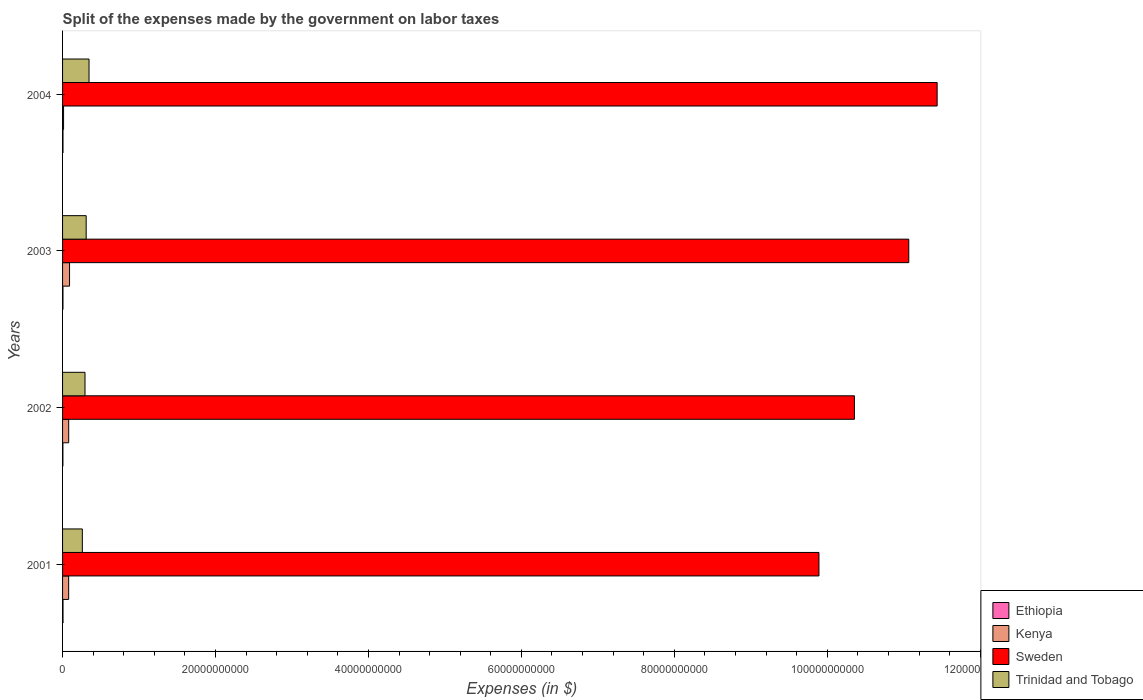How many different coloured bars are there?
Keep it short and to the point. 4. How many groups of bars are there?
Offer a terse response. 4. Are the number of bars on each tick of the Y-axis equal?
Provide a short and direct response. Yes. How many bars are there on the 3rd tick from the top?
Your answer should be compact. 4. How many bars are there on the 1st tick from the bottom?
Provide a short and direct response. 4. What is the label of the 1st group of bars from the top?
Ensure brevity in your answer.  2004. What is the expenses made by the government on labor taxes in Trinidad and Tobago in 2002?
Make the answer very short. 2.93e+09. Across all years, what is the maximum expenses made by the government on labor taxes in Sweden?
Your response must be concise. 1.14e+11. Across all years, what is the minimum expenses made by the government on labor taxes in Trinidad and Tobago?
Ensure brevity in your answer.  2.59e+09. In which year was the expenses made by the government on labor taxes in Trinidad and Tobago minimum?
Give a very brief answer. 2001. What is the total expenses made by the government on labor taxes in Sweden in the graph?
Your answer should be compact. 4.27e+11. What is the difference between the expenses made by the government on labor taxes in Trinidad and Tobago in 2002 and that in 2003?
Your answer should be very brief. -1.53e+08. What is the difference between the expenses made by the government on labor taxes in Ethiopia in 2003 and the expenses made by the government on labor taxes in Sweden in 2002?
Provide a succinct answer. -1.04e+11. What is the average expenses made by the government on labor taxes in Ethiopia per year?
Provide a succinct answer. 5.30e+07. In the year 2003, what is the difference between the expenses made by the government on labor taxes in Sweden and expenses made by the government on labor taxes in Kenya?
Keep it short and to the point. 1.10e+11. What is the ratio of the expenses made by the government on labor taxes in Trinidad and Tobago in 2001 to that in 2003?
Make the answer very short. 0.84. Is the expenses made by the government on labor taxes in Ethiopia in 2003 less than that in 2004?
Your answer should be compact. Yes. What is the difference between the highest and the lowest expenses made by the government on labor taxes in Sweden?
Provide a short and direct response. 1.55e+1. Is it the case that in every year, the sum of the expenses made by the government on labor taxes in Kenya and expenses made by the government on labor taxes in Sweden is greater than the sum of expenses made by the government on labor taxes in Trinidad and Tobago and expenses made by the government on labor taxes in Ethiopia?
Offer a terse response. Yes. What does the 3rd bar from the top in 2002 represents?
Ensure brevity in your answer.  Kenya. What does the 4th bar from the bottom in 2003 represents?
Provide a succinct answer. Trinidad and Tobago. Is it the case that in every year, the sum of the expenses made by the government on labor taxes in Trinidad and Tobago and expenses made by the government on labor taxes in Ethiopia is greater than the expenses made by the government on labor taxes in Sweden?
Provide a short and direct response. No. How many years are there in the graph?
Your answer should be compact. 4. What is the difference between two consecutive major ticks on the X-axis?
Your answer should be compact. 2.00e+1. How many legend labels are there?
Your response must be concise. 4. How are the legend labels stacked?
Your answer should be very brief. Vertical. What is the title of the graph?
Provide a short and direct response. Split of the expenses made by the government on labor taxes. Does "Montenegro" appear as one of the legend labels in the graph?
Make the answer very short. No. What is the label or title of the X-axis?
Make the answer very short. Expenses (in $). What is the Expenses (in $) of Ethiopia in 2001?
Provide a short and direct response. 5.79e+07. What is the Expenses (in $) of Kenya in 2001?
Provide a succinct answer. 7.97e+08. What is the Expenses (in $) of Sweden in 2001?
Keep it short and to the point. 9.89e+1. What is the Expenses (in $) of Trinidad and Tobago in 2001?
Offer a terse response. 2.59e+09. What is the Expenses (in $) of Ethiopia in 2002?
Your answer should be compact. 4.51e+07. What is the Expenses (in $) in Kenya in 2002?
Keep it short and to the point. 8.01e+08. What is the Expenses (in $) in Sweden in 2002?
Provide a short and direct response. 1.04e+11. What is the Expenses (in $) of Trinidad and Tobago in 2002?
Your answer should be very brief. 2.93e+09. What is the Expenses (in $) in Ethiopia in 2003?
Your answer should be compact. 5.20e+07. What is the Expenses (in $) of Kenya in 2003?
Offer a terse response. 9.14e+08. What is the Expenses (in $) of Sweden in 2003?
Keep it short and to the point. 1.11e+11. What is the Expenses (in $) of Trinidad and Tobago in 2003?
Your answer should be very brief. 3.09e+09. What is the Expenses (in $) in Ethiopia in 2004?
Ensure brevity in your answer.  5.71e+07. What is the Expenses (in $) of Kenya in 2004?
Provide a short and direct response. 1.31e+08. What is the Expenses (in $) in Sweden in 2004?
Keep it short and to the point. 1.14e+11. What is the Expenses (in $) in Trinidad and Tobago in 2004?
Your response must be concise. 3.46e+09. Across all years, what is the maximum Expenses (in $) in Ethiopia?
Offer a very short reply. 5.79e+07. Across all years, what is the maximum Expenses (in $) in Kenya?
Your answer should be compact. 9.14e+08. Across all years, what is the maximum Expenses (in $) of Sweden?
Ensure brevity in your answer.  1.14e+11. Across all years, what is the maximum Expenses (in $) of Trinidad and Tobago?
Offer a terse response. 3.46e+09. Across all years, what is the minimum Expenses (in $) of Ethiopia?
Offer a very short reply. 4.51e+07. Across all years, what is the minimum Expenses (in $) in Kenya?
Offer a very short reply. 1.31e+08. Across all years, what is the minimum Expenses (in $) of Sweden?
Ensure brevity in your answer.  9.89e+1. Across all years, what is the minimum Expenses (in $) in Trinidad and Tobago?
Your answer should be compact. 2.59e+09. What is the total Expenses (in $) of Ethiopia in the graph?
Give a very brief answer. 2.12e+08. What is the total Expenses (in $) in Kenya in the graph?
Your response must be concise. 2.64e+09. What is the total Expenses (in $) of Sweden in the graph?
Your answer should be very brief. 4.27e+11. What is the total Expenses (in $) in Trinidad and Tobago in the graph?
Provide a succinct answer. 1.21e+1. What is the difference between the Expenses (in $) of Ethiopia in 2001 and that in 2002?
Keep it short and to the point. 1.28e+07. What is the difference between the Expenses (in $) of Kenya in 2001 and that in 2002?
Keep it short and to the point. -4.44e+06. What is the difference between the Expenses (in $) of Sweden in 2001 and that in 2002?
Make the answer very short. -4.64e+09. What is the difference between the Expenses (in $) of Trinidad and Tobago in 2001 and that in 2002?
Your answer should be very brief. -3.48e+08. What is the difference between the Expenses (in $) in Ethiopia in 2001 and that in 2003?
Provide a succinct answer. 5.90e+06. What is the difference between the Expenses (in $) of Kenya in 2001 and that in 2003?
Offer a terse response. -1.17e+08. What is the difference between the Expenses (in $) of Sweden in 2001 and that in 2003?
Your response must be concise. -1.17e+1. What is the difference between the Expenses (in $) of Trinidad and Tobago in 2001 and that in 2003?
Your answer should be very brief. -5.01e+08. What is the difference between the Expenses (in $) of Kenya in 2001 and that in 2004?
Make the answer very short. 6.66e+08. What is the difference between the Expenses (in $) in Sweden in 2001 and that in 2004?
Provide a short and direct response. -1.55e+1. What is the difference between the Expenses (in $) in Trinidad and Tobago in 2001 and that in 2004?
Offer a terse response. -8.74e+08. What is the difference between the Expenses (in $) of Ethiopia in 2002 and that in 2003?
Provide a short and direct response. -6.90e+06. What is the difference between the Expenses (in $) of Kenya in 2002 and that in 2003?
Make the answer very short. -1.13e+08. What is the difference between the Expenses (in $) of Sweden in 2002 and that in 2003?
Provide a succinct answer. -7.11e+09. What is the difference between the Expenses (in $) of Trinidad and Tobago in 2002 and that in 2003?
Provide a succinct answer. -1.53e+08. What is the difference between the Expenses (in $) of Ethiopia in 2002 and that in 2004?
Your answer should be compact. -1.20e+07. What is the difference between the Expenses (in $) of Kenya in 2002 and that in 2004?
Keep it short and to the point. 6.70e+08. What is the difference between the Expenses (in $) of Sweden in 2002 and that in 2004?
Provide a succinct answer. -1.08e+1. What is the difference between the Expenses (in $) of Trinidad and Tobago in 2002 and that in 2004?
Offer a very short reply. -5.26e+08. What is the difference between the Expenses (in $) in Ethiopia in 2003 and that in 2004?
Give a very brief answer. -5.10e+06. What is the difference between the Expenses (in $) in Kenya in 2003 and that in 2004?
Your answer should be compact. 7.83e+08. What is the difference between the Expenses (in $) in Sweden in 2003 and that in 2004?
Make the answer very short. -3.71e+09. What is the difference between the Expenses (in $) of Trinidad and Tobago in 2003 and that in 2004?
Make the answer very short. -3.72e+08. What is the difference between the Expenses (in $) of Ethiopia in 2001 and the Expenses (in $) of Kenya in 2002?
Give a very brief answer. -7.43e+08. What is the difference between the Expenses (in $) in Ethiopia in 2001 and the Expenses (in $) in Sweden in 2002?
Offer a terse response. -1.03e+11. What is the difference between the Expenses (in $) in Ethiopia in 2001 and the Expenses (in $) in Trinidad and Tobago in 2002?
Offer a terse response. -2.88e+09. What is the difference between the Expenses (in $) in Kenya in 2001 and the Expenses (in $) in Sweden in 2002?
Ensure brevity in your answer.  -1.03e+11. What is the difference between the Expenses (in $) of Kenya in 2001 and the Expenses (in $) of Trinidad and Tobago in 2002?
Provide a short and direct response. -2.14e+09. What is the difference between the Expenses (in $) in Sweden in 2001 and the Expenses (in $) in Trinidad and Tobago in 2002?
Ensure brevity in your answer.  9.60e+1. What is the difference between the Expenses (in $) in Ethiopia in 2001 and the Expenses (in $) in Kenya in 2003?
Offer a terse response. -8.56e+08. What is the difference between the Expenses (in $) in Ethiopia in 2001 and the Expenses (in $) in Sweden in 2003?
Keep it short and to the point. -1.11e+11. What is the difference between the Expenses (in $) in Ethiopia in 2001 and the Expenses (in $) in Trinidad and Tobago in 2003?
Provide a short and direct response. -3.03e+09. What is the difference between the Expenses (in $) of Kenya in 2001 and the Expenses (in $) of Sweden in 2003?
Your answer should be compact. -1.10e+11. What is the difference between the Expenses (in $) in Kenya in 2001 and the Expenses (in $) in Trinidad and Tobago in 2003?
Make the answer very short. -2.29e+09. What is the difference between the Expenses (in $) in Sweden in 2001 and the Expenses (in $) in Trinidad and Tobago in 2003?
Make the answer very short. 9.58e+1. What is the difference between the Expenses (in $) of Ethiopia in 2001 and the Expenses (in $) of Kenya in 2004?
Offer a terse response. -7.31e+07. What is the difference between the Expenses (in $) of Ethiopia in 2001 and the Expenses (in $) of Sweden in 2004?
Make the answer very short. -1.14e+11. What is the difference between the Expenses (in $) in Ethiopia in 2001 and the Expenses (in $) in Trinidad and Tobago in 2004?
Your answer should be compact. -3.40e+09. What is the difference between the Expenses (in $) of Kenya in 2001 and the Expenses (in $) of Sweden in 2004?
Your answer should be very brief. -1.14e+11. What is the difference between the Expenses (in $) in Kenya in 2001 and the Expenses (in $) in Trinidad and Tobago in 2004?
Offer a very short reply. -2.66e+09. What is the difference between the Expenses (in $) in Sweden in 2001 and the Expenses (in $) in Trinidad and Tobago in 2004?
Your answer should be compact. 9.55e+1. What is the difference between the Expenses (in $) in Ethiopia in 2002 and the Expenses (in $) in Kenya in 2003?
Keep it short and to the point. -8.69e+08. What is the difference between the Expenses (in $) of Ethiopia in 2002 and the Expenses (in $) of Sweden in 2003?
Offer a terse response. -1.11e+11. What is the difference between the Expenses (in $) of Ethiopia in 2002 and the Expenses (in $) of Trinidad and Tobago in 2003?
Make the answer very short. -3.04e+09. What is the difference between the Expenses (in $) of Kenya in 2002 and the Expenses (in $) of Sweden in 2003?
Provide a short and direct response. -1.10e+11. What is the difference between the Expenses (in $) in Kenya in 2002 and the Expenses (in $) in Trinidad and Tobago in 2003?
Keep it short and to the point. -2.29e+09. What is the difference between the Expenses (in $) in Sweden in 2002 and the Expenses (in $) in Trinidad and Tobago in 2003?
Your answer should be very brief. 1.00e+11. What is the difference between the Expenses (in $) of Ethiopia in 2002 and the Expenses (in $) of Kenya in 2004?
Give a very brief answer. -8.59e+07. What is the difference between the Expenses (in $) in Ethiopia in 2002 and the Expenses (in $) in Sweden in 2004?
Ensure brevity in your answer.  -1.14e+11. What is the difference between the Expenses (in $) in Ethiopia in 2002 and the Expenses (in $) in Trinidad and Tobago in 2004?
Provide a succinct answer. -3.41e+09. What is the difference between the Expenses (in $) in Kenya in 2002 and the Expenses (in $) in Sweden in 2004?
Offer a very short reply. -1.14e+11. What is the difference between the Expenses (in $) in Kenya in 2002 and the Expenses (in $) in Trinidad and Tobago in 2004?
Provide a succinct answer. -2.66e+09. What is the difference between the Expenses (in $) in Sweden in 2002 and the Expenses (in $) in Trinidad and Tobago in 2004?
Offer a terse response. 1.00e+11. What is the difference between the Expenses (in $) in Ethiopia in 2003 and the Expenses (in $) in Kenya in 2004?
Your answer should be compact. -7.90e+07. What is the difference between the Expenses (in $) of Ethiopia in 2003 and the Expenses (in $) of Sweden in 2004?
Give a very brief answer. -1.14e+11. What is the difference between the Expenses (in $) in Ethiopia in 2003 and the Expenses (in $) in Trinidad and Tobago in 2004?
Offer a very short reply. -3.41e+09. What is the difference between the Expenses (in $) of Kenya in 2003 and the Expenses (in $) of Sweden in 2004?
Ensure brevity in your answer.  -1.13e+11. What is the difference between the Expenses (in $) in Kenya in 2003 and the Expenses (in $) in Trinidad and Tobago in 2004?
Your answer should be very brief. -2.55e+09. What is the difference between the Expenses (in $) of Sweden in 2003 and the Expenses (in $) of Trinidad and Tobago in 2004?
Make the answer very short. 1.07e+11. What is the average Expenses (in $) in Ethiopia per year?
Provide a short and direct response. 5.30e+07. What is the average Expenses (in $) in Kenya per year?
Provide a succinct answer. 6.61e+08. What is the average Expenses (in $) in Sweden per year?
Offer a terse response. 1.07e+11. What is the average Expenses (in $) of Trinidad and Tobago per year?
Offer a very short reply. 3.02e+09. In the year 2001, what is the difference between the Expenses (in $) in Ethiopia and Expenses (in $) in Kenya?
Your answer should be compact. -7.39e+08. In the year 2001, what is the difference between the Expenses (in $) of Ethiopia and Expenses (in $) of Sweden?
Your response must be concise. -9.89e+1. In the year 2001, what is the difference between the Expenses (in $) in Ethiopia and Expenses (in $) in Trinidad and Tobago?
Offer a terse response. -2.53e+09. In the year 2001, what is the difference between the Expenses (in $) of Kenya and Expenses (in $) of Sweden?
Provide a short and direct response. -9.81e+1. In the year 2001, what is the difference between the Expenses (in $) in Kenya and Expenses (in $) in Trinidad and Tobago?
Provide a short and direct response. -1.79e+09. In the year 2001, what is the difference between the Expenses (in $) in Sweden and Expenses (in $) in Trinidad and Tobago?
Keep it short and to the point. 9.63e+1. In the year 2002, what is the difference between the Expenses (in $) of Ethiopia and Expenses (in $) of Kenya?
Make the answer very short. -7.56e+08. In the year 2002, what is the difference between the Expenses (in $) in Ethiopia and Expenses (in $) in Sweden?
Keep it short and to the point. -1.04e+11. In the year 2002, what is the difference between the Expenses (in $) of Ethiopia and Expenses (in $) of Trinidad and Tobago?
Provide a succinct answer. -2.89e+09. In the year 2002, what is the difference between the Expenses (in $) of Kenya and Expenses (in $) of Sweden?
Provide a short and direct response. -1.03e+11. In the year 2002, what is the difference between the Expenses (in $) in Kenya and Expenses (in $) in Trinidad and Tobago?
Your answer should be compact. -2.13e+09. In the year 2002, what is the difference between the Expenses (in $) in Sweden and Expenses (in $) in Trinidad and Tobago?
Offer a terse response. 1.01e+11. In the year 2003, what is the difference between the Expenses (in $) in Ethiopia and Expenses (in $) in Kenya?
Keep it short and to the point. -8.62e+08. In the year 2003, what is the difference between the Expenses (in $) of Ethiopia and Expenses (in $) of Sweden?
Offer a terse response. -1.11e+11. In the year 2003, what is the difference between the Expenses (in $) of Ethiopia and Expenses (in $) of Trinidad and Tobago?
Keep it short and to the point. -3.04e+09. In the year 2003, what is the difference between the Expenses (in $) of Kenya and Expenses (in $) of Sweden?
Provide a succinct answer. -1.10e+11. In the year 2003, what is the difference between the Expenses (in $) in Kenya and Expenses (in $) in Trinidad and Tobago?
Make the answer very short. -2.17e+09. In the year 2003, what is the difference between the Expenses (in $) in Sweden and Expenses (in $) in Trinidad and Tobago?
Keep it short and to the point. 1.08e+11. In the year 2004, what is the difference between the Expenses (in $) in Ethiopia and Expenses (in $) in Kenya?
Ensure brevity in your answer.  -7.39e+07. In the year 2004, what is the difference between the Expenses (in $) in Ethiopia and Expenses (in $) in Sweden?
Make the answer very short. -1.14e+11. In the year 2004, what is the difference between the Expenses (in $) in Ethiopia and Expenses (in $) in Trinidad and Tobago?
Offer a terse response. -3.40e+09. In the year 2004, what is the difference between the Expenses (in $) in Kenya and Expenses (in $) in Sweden?
Make the answer very short. -1.14e+11. In the year 2004, what is the difference between the Expenses (in $) of Kenya and Expenses (in $) of Trinidad and Tobago?
Offer a terse response. -3.33e+09. In the year 2004, what is the difference between the Expenses (in $) of Sweden and Expenses (in $) of Trinidad and Tobago?
Make the answer very short. 1.11e+11. What is the ratio of the Expenses (in $) of Ethiopia in 2001 to that in 2002?
Keep it short and to the point. 1.28. What is the ratio of the Expenses (in $) in Kenya in 2001 to that in 2002?
Make the answer very short. 0.99. What is the ratio of the Expenses (in $) of Sweden in 2001 to that in 2002?
Make the answer very short. 0.96. What is the ratio of the Expenses (in $) of Trinidad and Tobago in 2001 to that in 2002?
Ensure brevity in your answer.  0.88. What is the ratio of the Expenses (in $) in Ethiopia in 2001 to that in 2003?
Make the answer very short. 1.11. What is the ratio of the Expenses (in $) of Kenya in 2001 to that in 2003?
Your answer should be very brief. 0.87. What is the ratio of the Expenses (in $) of Sweden in 2001 to that in 2003?
Your response must be concise. 0.89. What is the ratio of the Expenses (in $) of Trinidad and Tobago in 2001 to that in 2003?
Offer a very short reply. 0.84. What is the ratio of the Expenses (in $) of Kenya in 2001 to that in 2004?
Your answer should be compact. 6.08. What is the ratio of the Expenses (in $) of Sweden in 2001 to that in 2004?
Offer a very short reply. 0.86. What is the ratio of the Expenses (in $) of Trinidad and Tobago in 2001 to that in 2004?
Provide a short and direct response. 0.75. What is the ratio of the Expenses (in $) in Ethiopia in 2002 to that in 2003?
Give a very brief answer. 0.87. What is the ratio of the Expenses (in $) in Kenya in 2002 to that in 2003?
Offer a terse response. 0.88. What is the ratio of the Expenses (in $) of Sweden in 2002 to that in 2003?
Offer a terse response. 0.94. What is the ratio of the Expenses (in $) in Trinidad and Tobago in 2002 to that in 2003?
Your answer should be very brief. 0.95. What is the ratio of the Expenses (in $) in Ethiopia in 2002 to that in 2004?
Offer a very short reply. 0.79. What is the ratio of the Expenses (in $) of Kenya in 2002 to that in 2004?
Your answer should be compact. 6.11. What is the ratio of the Expenses (in $) of Sweden in 2002 to that in 2004?
Your response must be concise. 0.91. What is the ratio of the Expenses (in $) of Trinidad and Tobago in 2002 to that in 2004?
Provide a short and direct response. 0.85. What is the ratio of the Expenses (in $) in Ethiopia in 2003 to that in 2004?
Offer a very short reply. 0.91. What is the ratio of the Expenses (in $) of Kenya in 2003 to that in 2004?
Your answer should be very brief. 6.97. What is the ratio of the Expenses (in $) of Sweden in 2003 to that in 2004?
Your answer should be compact. 0.97. What is the ratio of the Expenses (in $) in Trinidad and Tobago in 2003 to that in 2004?
Give a very brief answer. 0.89. What is the difference between the highest and the second highest Expenses (in $) of Ethiopia?
Offer a very short reply. 8.00e+05. What is the difference between the highest and the second highest Expenses (in $) in Kenya?
Offer a very short reply. 1.13e+08. What is the difference between the highest and the second highest Expenses (in $) in Sweden?
Make the answer very short. 3.71e+09. What is the difference between the highest and the second highest Expenses (in $) of Trinidad and Tobago?
Provide a short and direct response. 3.72e+08. What is the difference between the highest and the lowest Expenses (in $) of Ethiopia?
Your answer should be compact. 1.28e+07. What is the difference between the highest and the lowest Expenses (in $) in Kenya?
Provide a succinct answer. 7.83e+08. What is the difference between the highest and the lowest Expenses (in $) in Sweden?
Keep it short and to the point. 1.55e+1. What is the difference between the highest and the lowest Expenses (in $) in Trinidad and Tobago?
Your answer should be very brief. 8.74e+08. 